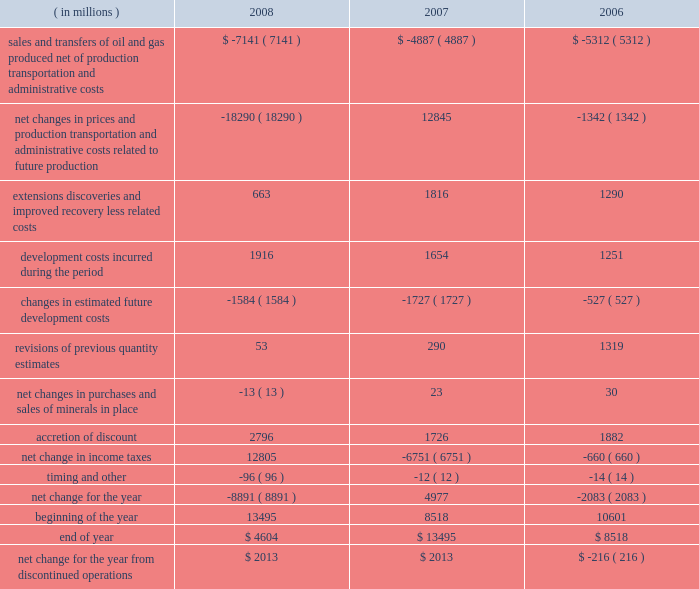Supplementary information on oil and gas producing activities ( unaudited ) c o n t i n u e d summary of changes in standardized measure of discounted future net cash flows relating to proved oil and gas reserves ( in millions ) 2008 2007 2006 sales and transfers of oil and gas produced , net of production , transportation and administrative costs $ ( 7141 ) $ ( 4887 ) $ ( 5312 ) net changes in prices and production , transportation and administrative costs related to future production ( 18290 ) 12845 ( 1342 ) .

What is the average discounted cash flow balance for the three year period , in millions? 
Computations: table_average(end of year, none)
Answer: 8872.33333. 